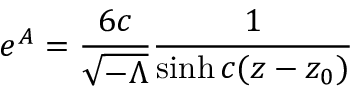<formula> <loc_0><loc_0><loc_500><loc_500>e ^ { A } = \frac { 6 c } { { \sqrt { - \Lambda } } } \frac { 1 } { \sinh c ( z - z _ { 0 } ) }</formula> 